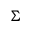<formula> <loc_0><loc_0><loc_500><loc_500>\Sigma</formula> 